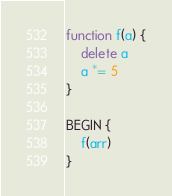Convert code to text. <code><loc_0><loc_0><loc_500><loc_500><_Awk_>function f(a) {
	delete a
	a *= 5
}

BEGIN {
	f(arr)
}
</code> 